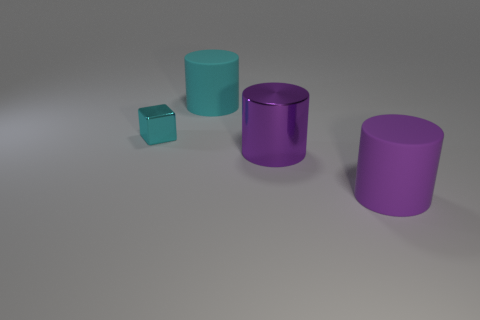What number of other things are the same color as the metallic cube?
Keep it short and to the point. 1. There is a purple shiny object; are there any small cyan metallic blocks behind it?
Provide a succinct answer. Yes. How many objects are either tiny green metal objects or cylinders that are behind the tiny cyan block?
Make the answer very short. 1. Are there any metal cylinders to the right of the rubber object in front of the tiny metallic object?
Offer a very short reply. No. There is a purple thing to the right of the big purple cylinder that is on the left side of the big purple cylinder to the right of the purple shiny object; what shape is it?
Your answer should be very brief. Cylinder. What color is the thing that is both behind the large purple metal cylinder and on the right side of the cyan metal cube?
Offer a terse response. Cyan. There is a cyan object that is in front of the big cyan cylinder; what shape is it?
Provide a succinct answer. Cube. The purple thing that is made of the same material as the cyan cylinder is what shape?
Make the answer very short. Cylinder. How many rubber objects are either yellow balls or tiny things?
Your answer should be compact. 0. There is a cyan shiny object in front of the cyan thing that is behind the small cyan shiny block; how many big purple cylinders are behind it?
Your response must be concise. 0. 